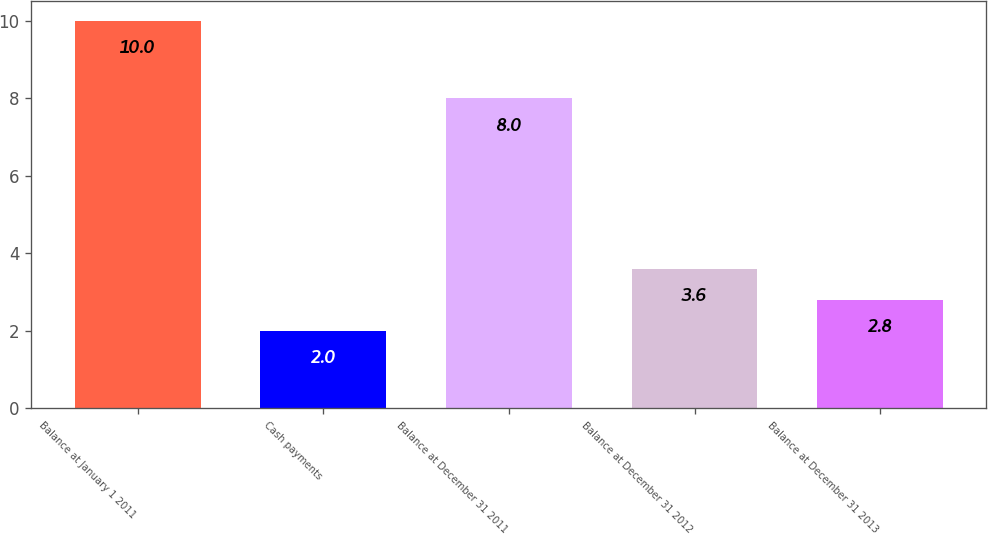<chart> <loc_0><loc_0><loc_500><loc_500><bar_chart><fcel>Balance at January 1 2011<fcel>Cash payments<fcel>Balance at December 31 2011<fcel>Balance at December 31 2012<fcel>Balance at December 31 2013<nl><fcel>10<fcel>2<fcel>8<fcel>3.6<fcel>2.8<nl></chart> 